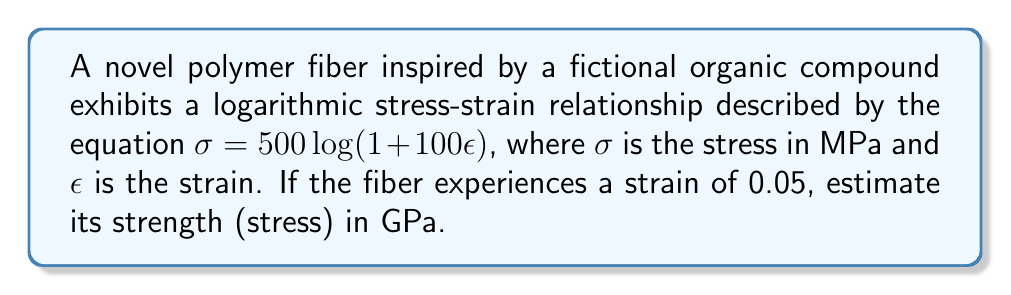Can you answer this question? To solve this problem, we'll follow these steps:

1) We're given the stress-strain relationship:
   $\sigma = 500 \log(1 + 100\epsilon)$

2) We need to find $\sigma$ when $\epsilon = 0.05$

3) Let's substitute $\epsilon = 0.05$ into the equation:
   $\sigma = 500 \log(1 + 100(0.05))$

4) Simplify inside the parentheses:
   $\sigma = 500 \log(1 + 5)$
   $\sigma = 500 \log(6)$

5) Calculate $\log(6)$ (using base 10 logarithm):
   $\log(6) \approx 0.7781513$

6) Multiply by 500:
   $\sigma = 500 * 0.7781513 \approx 389.07565$ MPa

7) Convert MPa to GPa:
   $389.07565$ MPa = $0.38907565$ GPa

8) Round to three significant figures:
   $0.389$ GPa

Therefore, the estimated strength of the polymer fiber at a strain of 0.05 is 0.389 GPa.
Answer: 0.389 GPa 